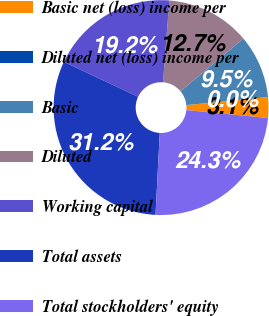Convert chart to OTSL. <chart><loc_0><loc_0><loc_500><loc_500><pie_chart><fcel>Basic net (loss) income per<fcel>Diluted net (loss) income per<fcel>Basic<fcel>Diluted<fcel>Working capital<fcel>Total assets<fcel>Total stockholders' equity<nl><fcel>3.12%<fcel>0.0%<fcel>9.54%<fcel>12.66%<fcel>19.23%<fcel>31.18%<fcel>24.27%<nl></chart> 